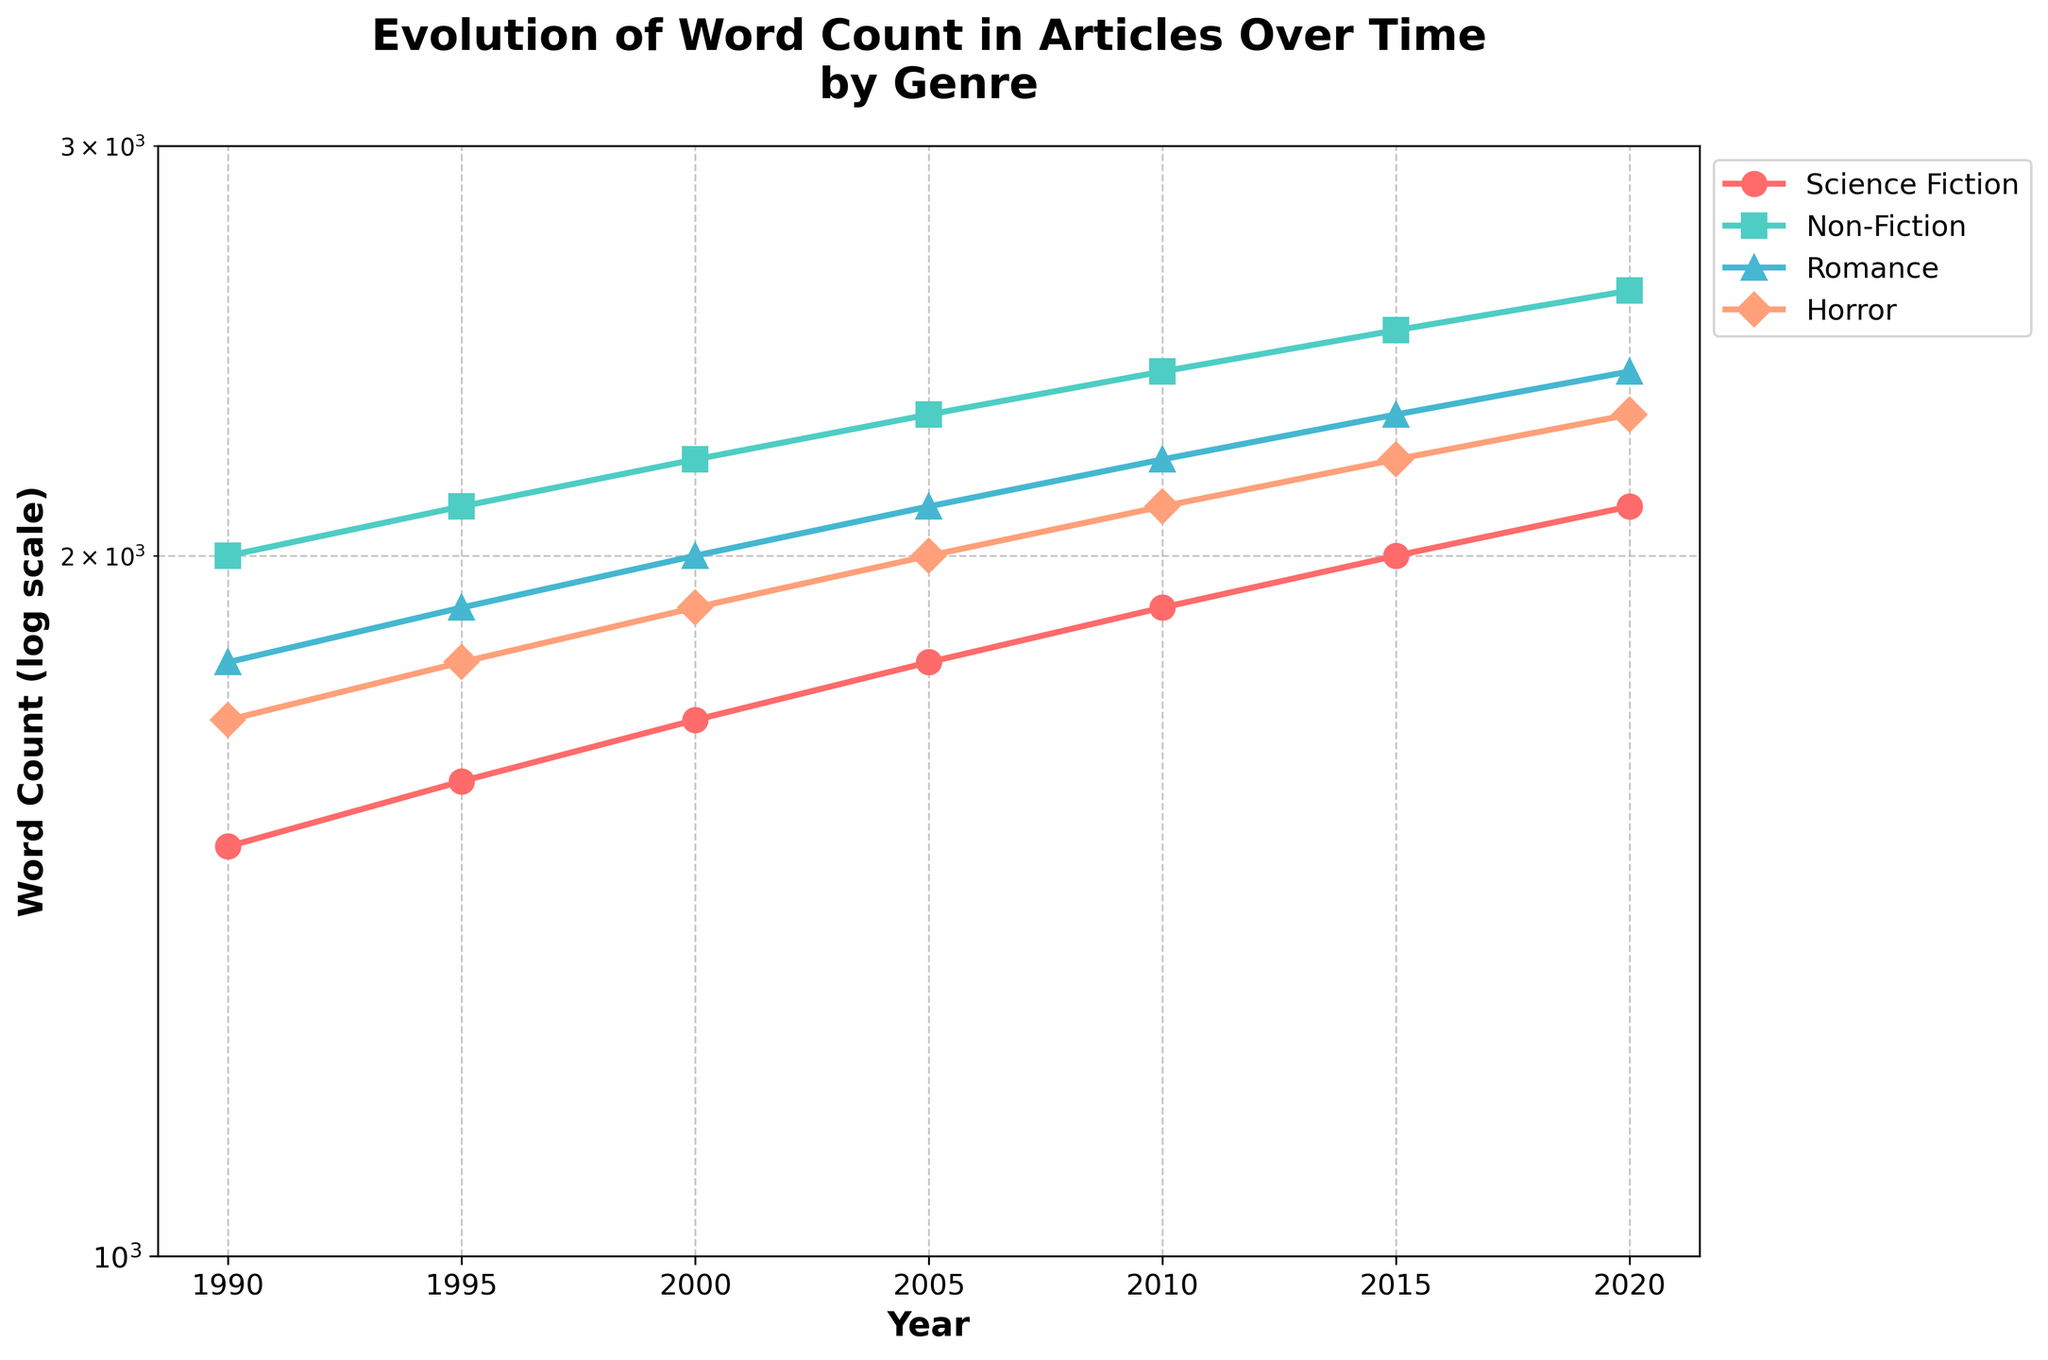What is the title of the figure? The title is displayed prominently at the top of the figure, helping viewers instantly understand the purpose of the visualization. The title reads "Evolution of Word Count in Articles Over Time by Genre".
Answer: Evolution of Word Count in Articles Over Time by Genre Which genre has the highest word count in 2020? To find this, look at the data points for the year 2020. The highest point corresponds to the "Non-Fiction" genre, which reaches 2600 words, indicated by the 's' marker and the greenish color.
Answer: Non-Fiction How has the word count for Science Fiction articles changed from 1990 to 2020? To answer this, trace the line representing Science Fiction from 1990 to 2020. The word count increases from 1500 in 1990 to 2100 in 2020. The change is 2100 - 1500 = 600 words.
Answer: Increased by 600 words Compare the word count trends between the "Romance" and "Horror" genres from 1990 to 2020. Which genre had a steeper increase? To compare, look at both the start and end points for each genre. "Romance" starts at 1800 and ends at 2400, a 600-word increase. "Horror" starts at 1700 and ends at 2300, also a 600-word increase. Both genres show an equal increase in word count over time.
Answer: They have an equal increase What is the word count for Non-Fiction articles in 2010? Locate the specific data point for Non-Fiction articles in the year 2010. The "Non-Fiction" line shows a word count of 2400 for this year.
Answer: 2400 List all the word counts for the Horror genre shown in the figure. To list these, follow the Horror line through the years 1990, 1995, 2000, 2005, 2010, 2015, and 2020. The word counts are 1700, 1800, 1900, 2000, 2100, 2200, and 2300 respectively.
Answer: 1700, 1800, 1900, 2000, 2100, 2200, 2300 What is the difference in word count between Romance and Science Fiction articles in 2005? In 2005, the word count for Romance is 2100, and for Science Fiction, it is 1800. The difference is 2100 - 1800 = 300 words.
Answer: 300 words How many distinct genres are present in the figure? By identifying the unique markers and colors representing distinct lines on the plot, it's apparent there are four distinct genres: Science Fiction, Non-Fiction, Romance, and Horror.
Answer: Four genres 